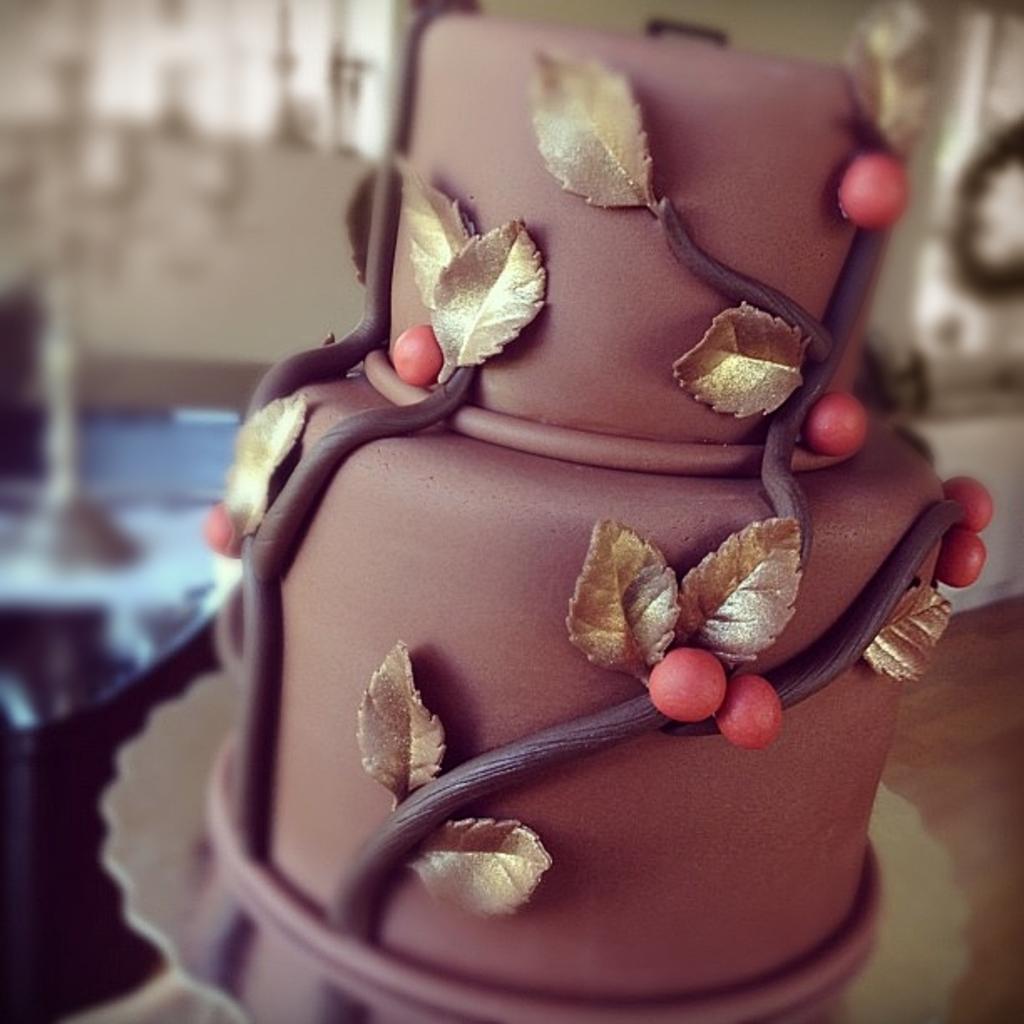How would you summarize this image in a sentence or two? In the picture I can see a cake on a plate. The background of the image is blurred. 